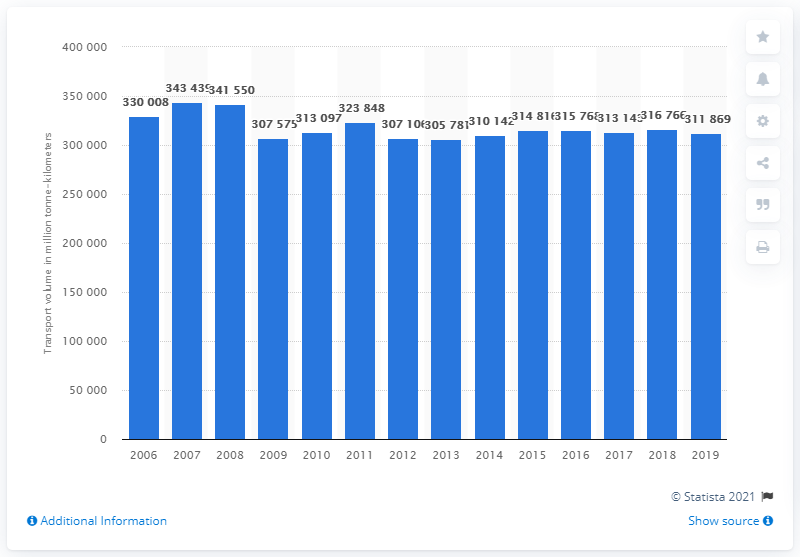List a handful of essential elements in this visual. The highest transport volume was achieved in 2007. In 2019, the transport volume in the road freight sector in Germany was 311,869. 